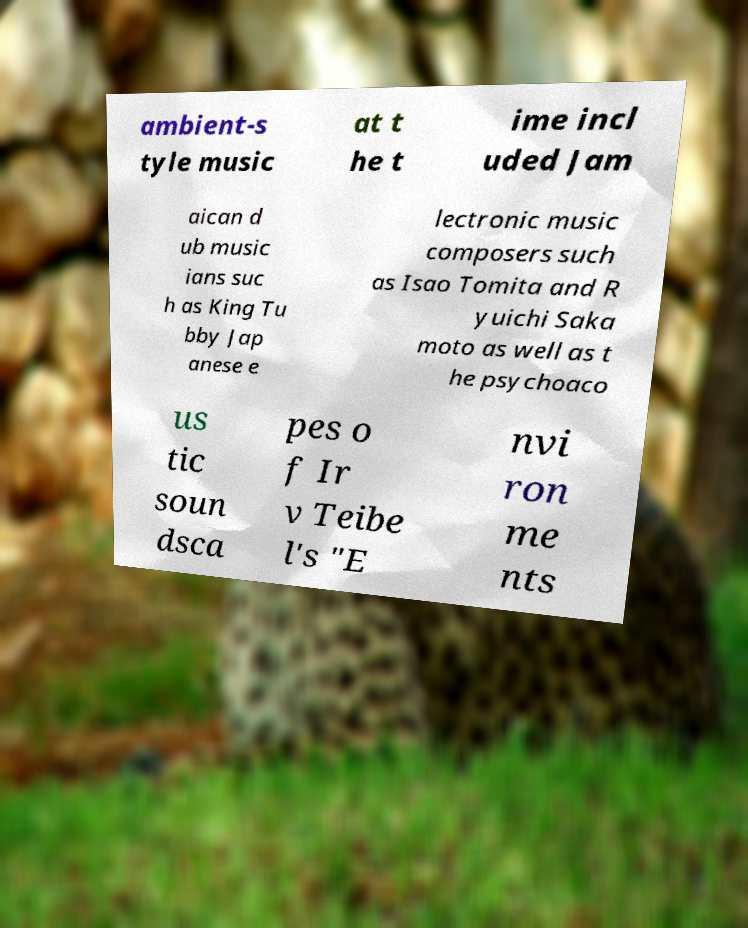What messages or text are displayed in this image? I need them in a readable, typed format. ambient-s tyle music at t he t ime incl uded Jam aican d ub music ians suc h as King Tu bby Jap anese e lectronic music composers such as Isao Tomita and R yuichi Saka moto as well as t he psychoaco us tic soun dsca pes o f Ir v Teibe l's "E nvi ron me nts 